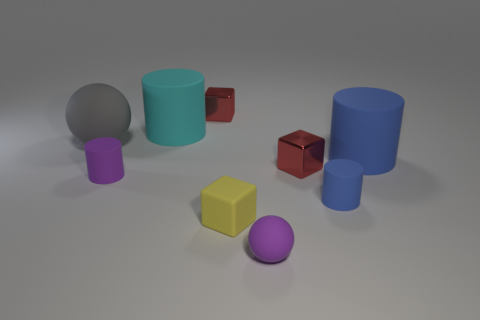Subtract all green spheres. Subtract all red cylinders. How many spheres are left? 2 Subtract all spheres. How many objects are left? 7 Add 1 balls. How many balls exist? 3 Subtract 1 blue cylinders. How many objects are left? 8 Subtract all big cyan cylinders. Subtract all small purple matte things. How many objects are left? 6 Add 7 large objects. How many large objects are left? 10 